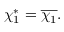Convert formula to latex. <formula><loc_0><loc_0><loc_500><loc_500>\chi _ { 1 } ^ { * } = { \overline { { \chi _ { 1 } } } } .</formula> 